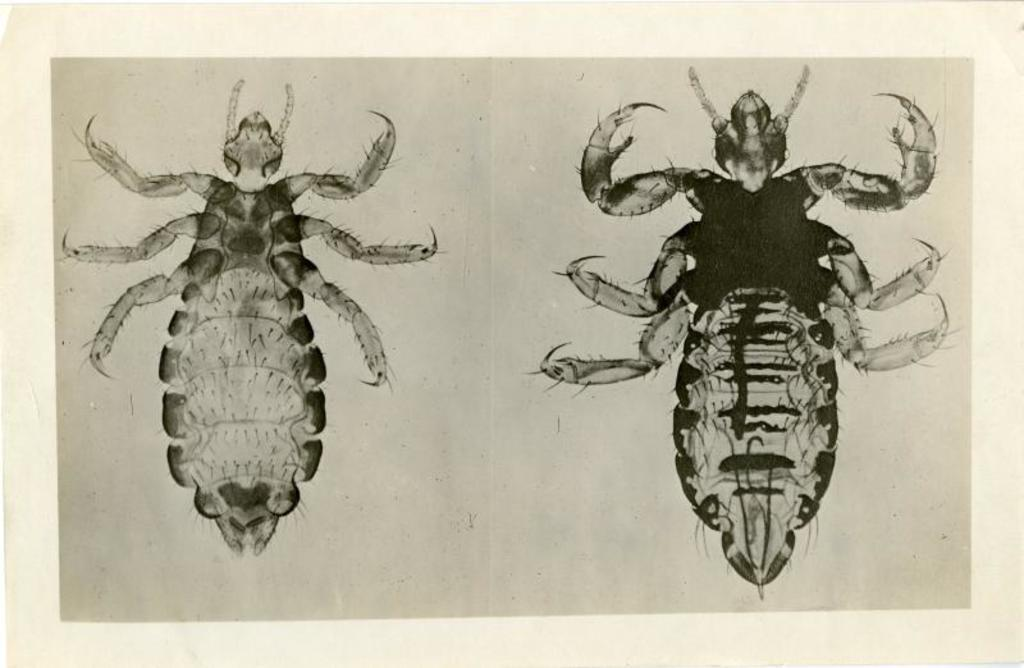What is present in the image? There is a poster in the image. What can be seen on the poster? The poster contains images of insects. What type of thread is used to create the cobweb in the image? There is no cobweb present in the image; it only contains a poster with images of insects. What kind of brush is used to paint the insects on the poster? The image does not provide information about the tools or techniques used to create the poster, so we cannot determine the type of brush used. 